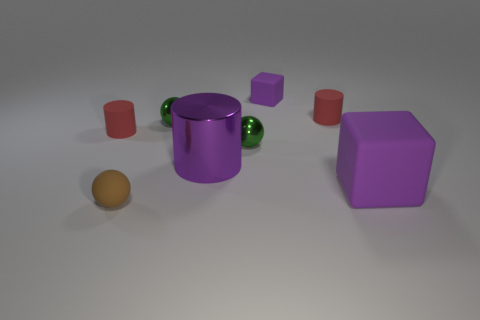What number of green things are either rubber cylinders or small metallic spheres?
Your answer should be compact. 2. What number of small objects are on the left side of the purple cylinder and behind the small matte sphere?
Offer a very short reply. 2. What is the material of the large thing to the left of the purple block that is behind the small green metallic ball that is on the left side of the big cylinder?
Provide a short and direct response. Metal. What number of purple cylinders are the same material as the tiny brown ball?
Keep it short and to the point. 0. What shape is the tiny object that is the same color as the large shiny thing?
Offer a terse response. Cube. What shape is the object that is the same size as the purple cylinder?
Ensure brevity in your answer.  Cube. There is a cylinder that is the same color as the big rubber object; what is it made of?
Offer a very short reply. Metal. There is a large purple shiny thing; are there any small rubber cylinders in front of it?
Your answer should be very brief. No. Is there another object that has the same shape as the large purple matte object?
Provide a short and direct response. Yes. Is the shape of the large purple object that is behind the big block the same as the tiny object that is in front of the big purple metallic cylinder?
Your answer should be very brief. No. 